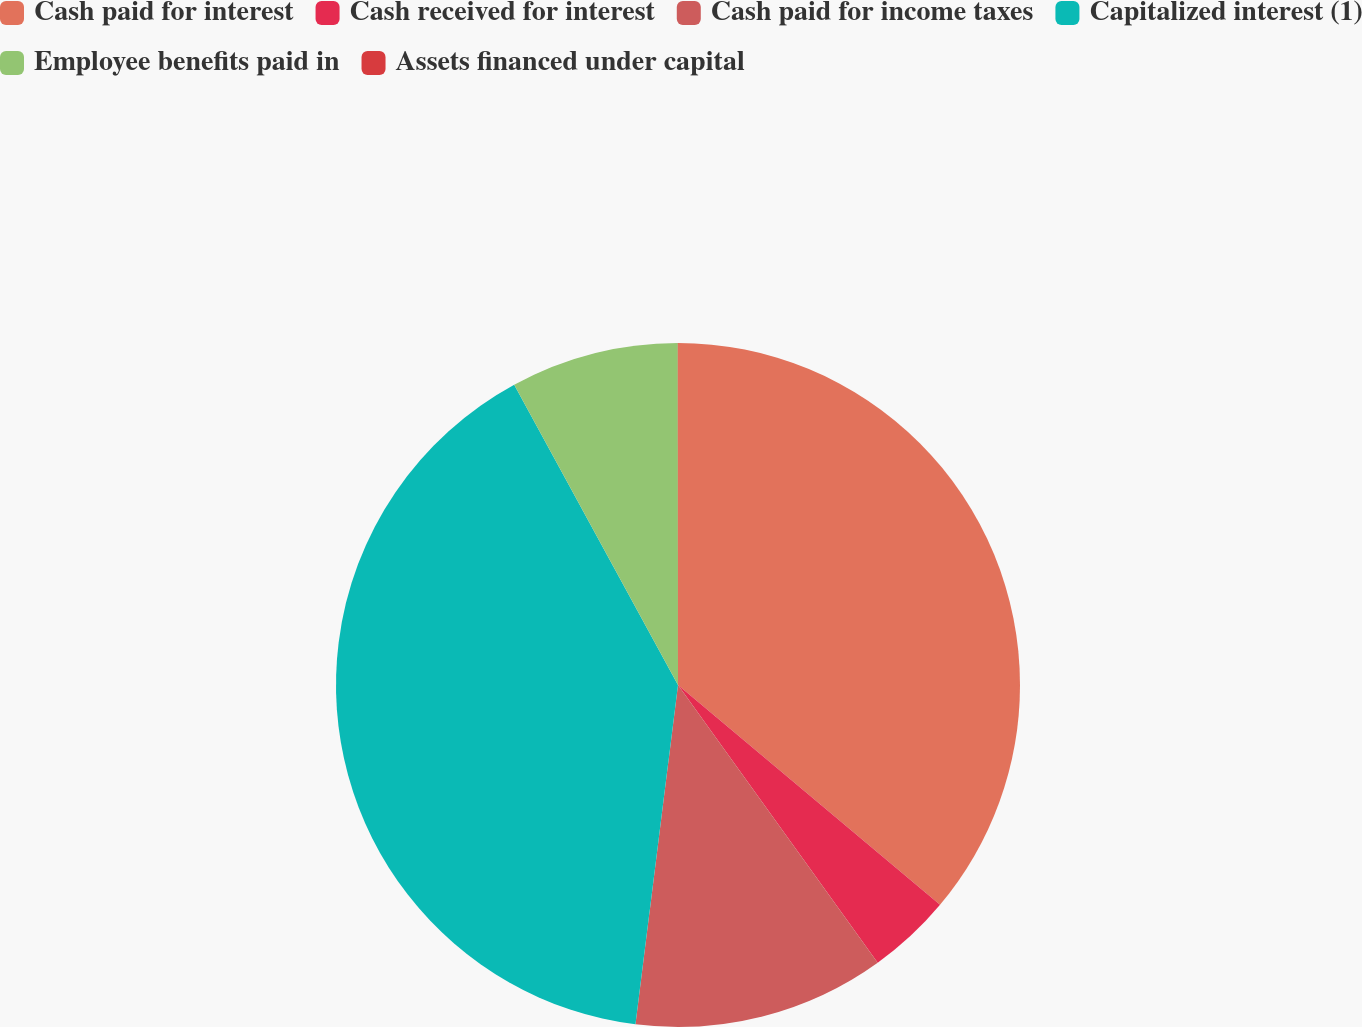Convert chart. <chart><loc_0><loc_0><loc_500><loc_500><pie_chart><fcel>Cash paid for interest<fcel>Cash received for interest<fcel>Cash paid for income taxes<fcel>Capitalized interest (1)<fcel>Employee benefits paid in<fcel>Assets financed under capital<nl><fcel>36.11%<fcel>3.97%<fcel>11.91%<fcel>40.07%<fcel>7.94%<fcel>0.01%<nl></chart> 